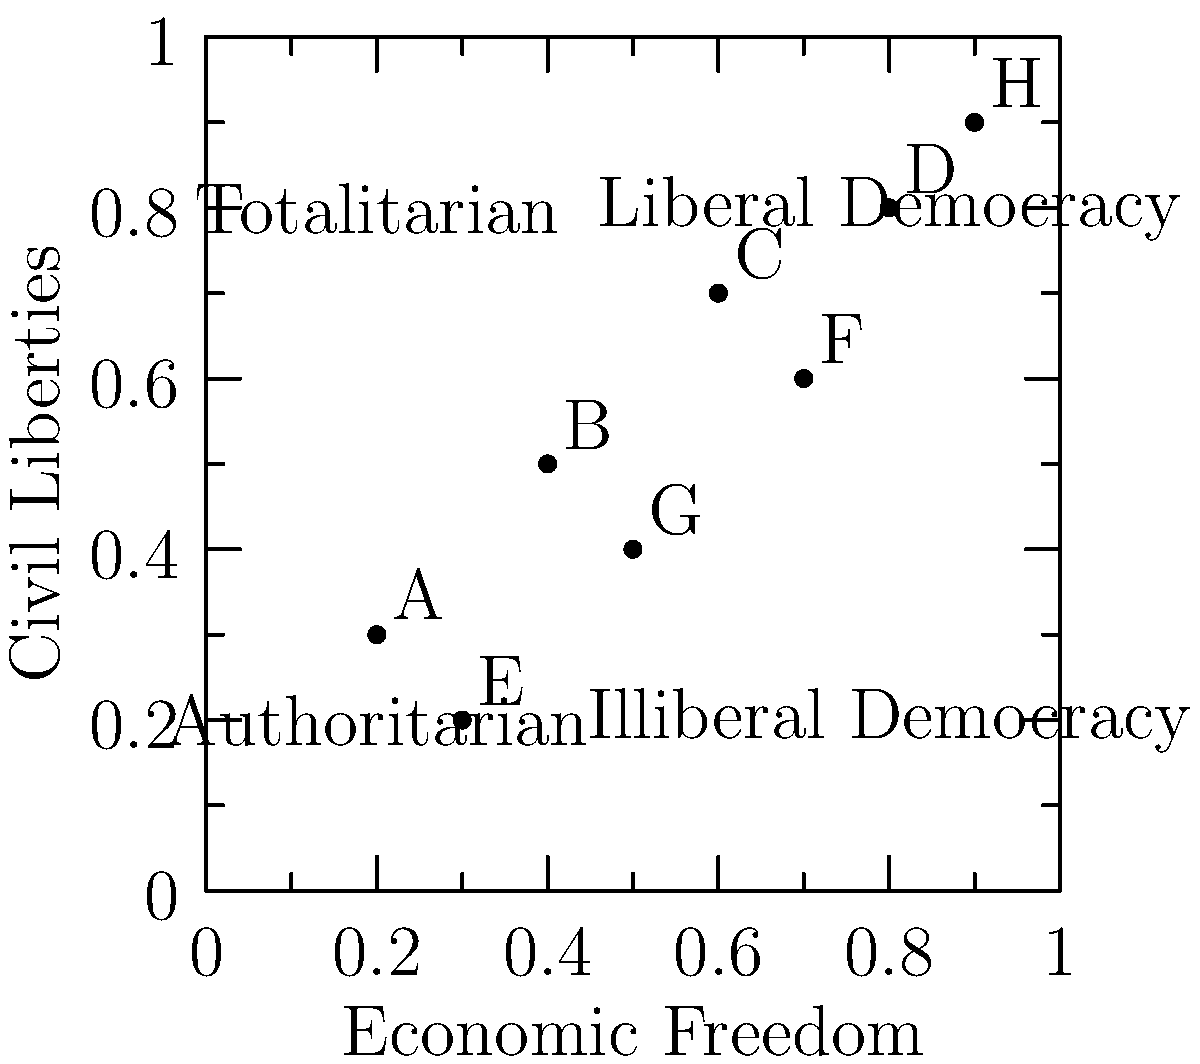Based on the scatter plot showing the relationship between civil liberties and economic freedom for different political regimes, which country is most likely to be classified as an illiberal democracy? To identify an illiberal democracy from the scatter plot, we need to follow these steps:

1. Understand the characteristics of an illiberal democracy:
   - High economic freedom
   - Low civil liberties

2. Locate the quadrant representing illiberal democracies:
   - Bottom-right quadrant of the plot

3. Analyze the data points:
   - Look for points in or closest to the bottom-right quadrant

4. Identify the country:
   - Country F is located in the bottom-right quadrant
   - It has relatively high economic freedom (around 0.7)
   - It has relatively low civil liberties (around 0.6)

5. Compare with other countries:
   - No other country falls as clearly in the illiberal democracy category

6. Conclude:
   - Country F best fits the characteristics of an illiberal democracy among the given options
Answer: Country F 